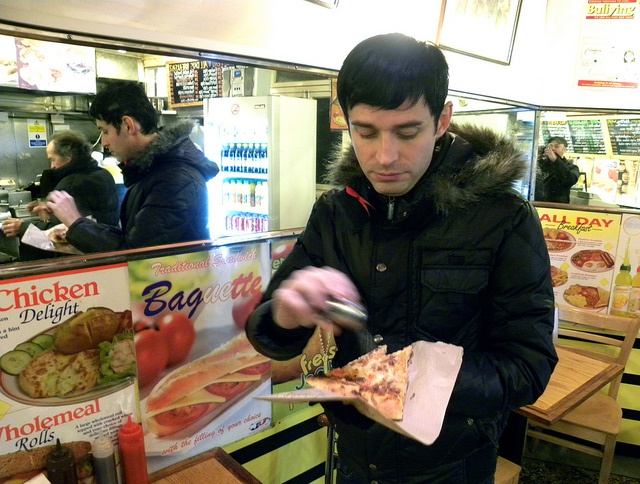Describe the objects in this image and their specific colors. I can see people in darkgray, black, and gray tones, people in darkgray, black, gray, navy, and olive tones, chair in darkgray, olive, black, and tan tones, dining table in darkgray, tan, olive, black, and maroon tones, and pizza in darkgray, tan, and salmon tones in this image. 